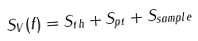<formula> <loc_0><loc_0><loc_500><loc_500>S _ { V } ( f ) = S _ { t h } + S _ { p t } + S _ { s a m p l e }</formula> 